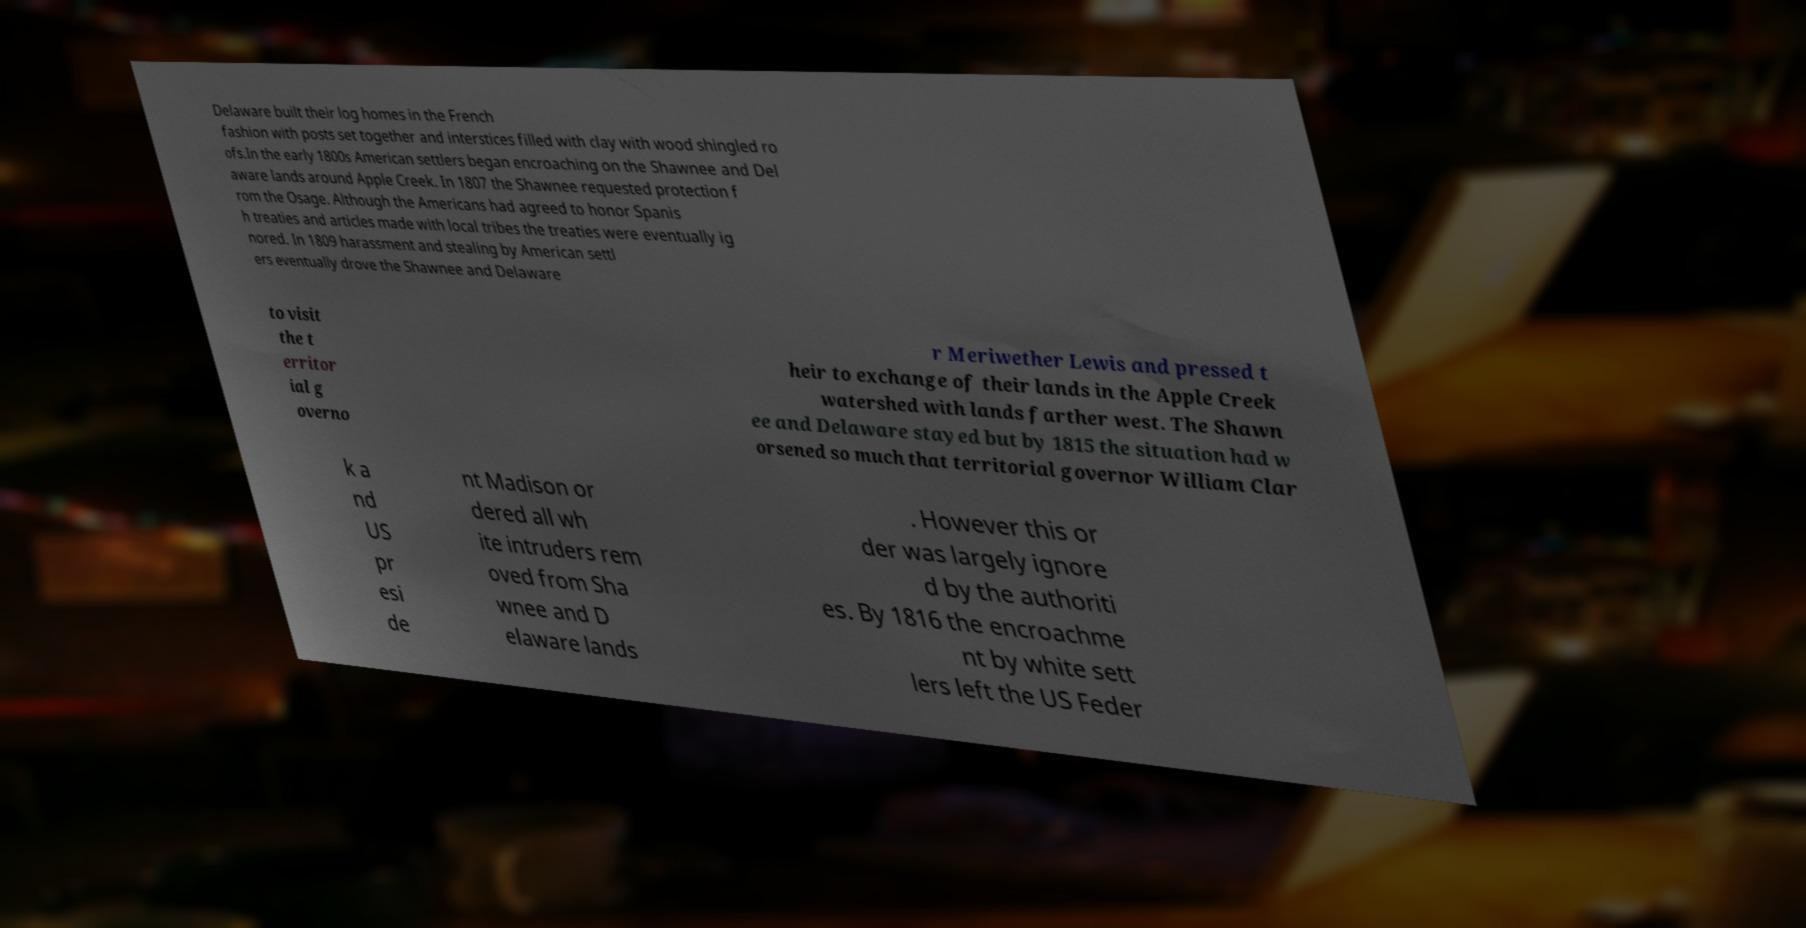Can you read and provide the text displayed in the image?This photo seems to have some interesting text. Can you extract and type it out for me? Delaware built their log homes in the French fashion with posts set together and interstices filled with clay with wood shingled ro ofs.In the early 1800s American settlers began encroaching on the Shawnee and Del aware lands around Apple Creek. In 1807 the Shawnee requested protection f rom the Osage. Although the Americans had agreed to honor Spanis h treaties and articles made with local tribes the treaties were eventually ig nored. In 1809 harassment and stealing by American settl ers eventually drove the Shawnee and Delaware to visit the t erritor ial g overno r Meriwether Lewis and pressed t heir to exchange of their lands in the Apple Creek watershed with lands farther west. The Shawn ee and Delaware stayed but by 1815 the situation had w orsened so much that territorial governor William Clar k a nd US pr esi de nt Madison or dered all wh ite intruders rem oved from Sha wnee and D elaware lands . However this or der was largely ignore d by the authoriti es. By 1816 the encroachme nt by white sett lers left the US Feder 